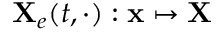Convert formula to latex. <formula><loc_0><loc_0><loc_500><loc_500>{ X } _ { e } ( t , \cdot ) \colon { x } \mapsto { X }</formula> 